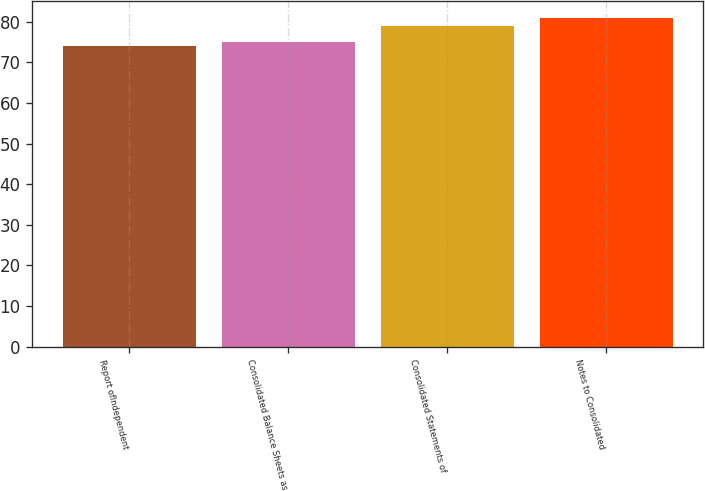Convert chart. <chart><loc_0><loc_0><loc_500><loc_500><bar_chart><fcel>Report oflndependent<fcel>Consolidated Balance Sheets as<fcel>Consolidated Statements of<fcel>Notes to Consolidated<nl><fcel>74<fcel>75<fcel>79<fcel>81<nl></chart> 